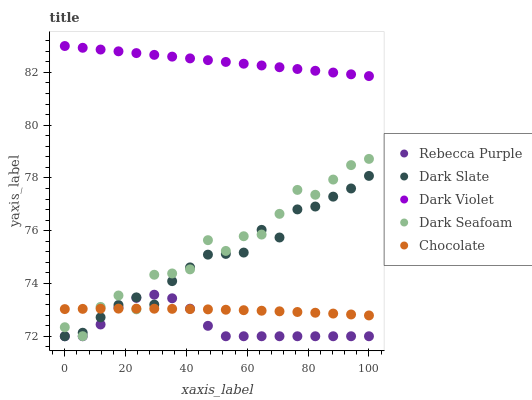Does Rebecca Purple have the minimum area under the curve?
Answer yes or no. Yes. Does Dark Violet have the maximum area under the curve?
Answer yes or no. Yes. Does Dark Seafoam have the minimum area under the curve?
Answer yes or no. No. Does Dark Seafoam have the maximum area under the curve?
Answer yes or no. No. Is Dark Violet the smoothest?
Answer yes or no. Yes. Is Dark Seafoam the roughest?
Answer yes or no. Yes. Is Rebecca Purple the smoothest?
Answer yes or no. No. Is Rebecca Purple the roughest?
Answer yes or no. No. Does Dark Slate have the lowest value?
Answer yes or no. Yes. Does Dark Seafoam have the lowest value?
Answer yes or no. No. Does Dark Violet have the highest value?
Answer yes or no. Yes. Does Dark Seafoam have the highest value?
Answer yes or no. No. Is Rebecca Purple less than Dark Violet?
Answer yes or no. Yes. Is Dark Violet greater than Rebecca Purple?
Answer yes or no. Yes. Does Rebecca Purple intersect Dark Seafoam?
Answer yes or no. Yes. Is Rebecca Purple less than Dark Seafoam?
Answer yes or no. No. Is Rebecca Purple greater than Dark Seafoam?
Answer yes or no. No. Does Rebecca Purple intersect Dark Violet?
Answer yes or no. No. 